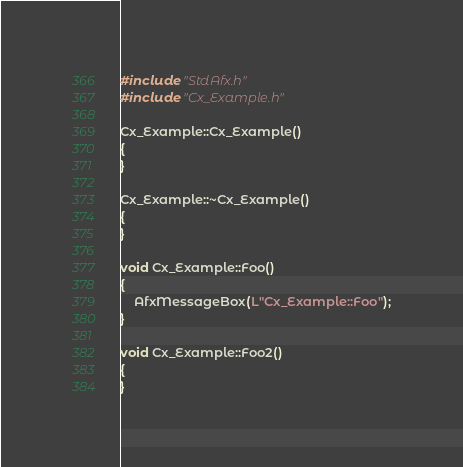Convert code to text. <code><loc_0><loc_0><loc_500><loc_500><_C++_>#include "StdAfx.h"
#include "Cx_Example.h"

Cx_Example::Cx_Example()
{
}

Cx_Example::~Cx_Example()
{
}

void Cx_Example::Foo()
{
	AfxMessageBox(L"Cx_Example::Foo");
}

void Cx_Example::Foo2()
{
}
</code> 